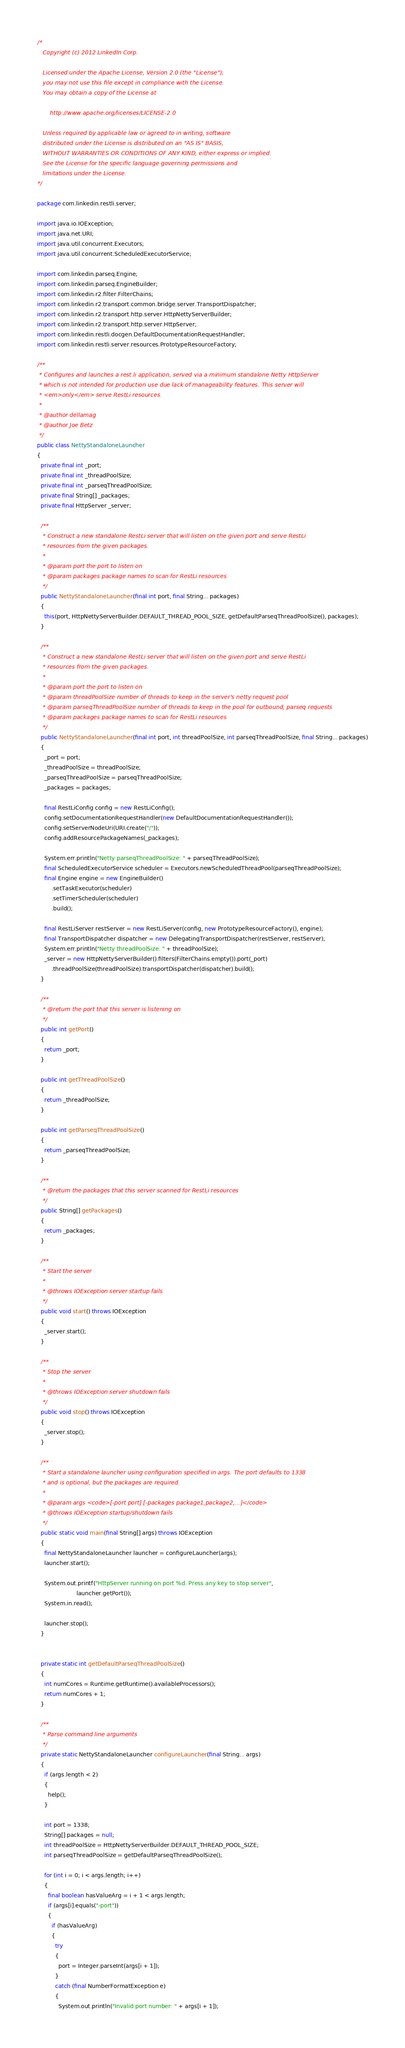<code> <loc_0><loc_0><loc_500><loc_500><_Java_>/*
   Copyright (c) 2012 LinkedIn Corp.

   Licensed under the Apache License, Version 2.0 (the "License");
   you may not use this file except in compliance with the License.
   You may obtain a copy of the License at

       http://www.apache.org/licenses/LICENSE-2.0

   Unless required by applicable law or agreed to in writing, software
   distributed under the License is distributed on an "AS IS" BASIS,
   WITHOUT WARRANTIES OR CONDITIONS OF ANY KIND, either express or implied.
   See the License for the specific language governing permissions and
   limitations under the License.
*/

package com.linkedin.restli.server;

import java.io.IOException;
import java.net.URI;
import java.util.concurrent.Executors;
import java.util.concurrent.ScheduledExecutorService;

import com.linkedin.parseq.Engine;
import com.linkedin.parseq.EngineBuilder;
import com.linkedin.r2.filter.FilterChains;
import com.linkedin.r2.transport.common.bridge.server.TransportDispatcher;
import com.linkedin.r2.transport.http.server.HttpNettyServerBuilder;
import com.linkedin.r2.transport.http.server.HttpServer;
import com.linkedin.restli.docgen.DefaultDocumentationRequestHandler;
import com.linkedin.restli.server.resources.PrototypeResourceFactory;

/**
 * Configures and launches a rest.li application, served via a minimum standalone Netty HttpServer
 * which is not intended for production use due lack of manageability features. This server will
 * <em>only</em> serve RestLi resources.
 *
 * @author dellamag
 * @author Joe Betz
 */
public class NettyStandaloneLauncher
{
  private final int _port;
  private final int _threadPoolSize;
  private final int _parseqThreadPoolSize;
  private final String[] _packages;
  private final HttpServer _server;

  /**
   * Construct a new standalone RestLi server that will listen on the given port and serve RestLi
   * resources from the given packages.
   *
   * @param port the port to listen on
   * @param packages package names to scan for RestLi resources
   */
  public NettyStandaloneLauncher(final int port, final String... packages)
  {
    this(port, HttpNettyServerBuilder.DEFAULT_THREAD_POOL_SIZE, getDefaultParseqThreadPoolSize(), packages);
  }

  /**
   * Construct a new standalone RestLi server that will listen on the given port and serve RestLi
   * resources from the given packages.
   *
   * @param port the port to listen on
   * @param threadPoolSize number of threads to keep in the server's netty request pool
   * @param parseqThreadPoolSize number of threads to keep in the pool for outbound, parseq requests
   * @param packages package names to scan for RestLi resources
   */
  public NettyStandaloneLauncher(final int port, int threadPoolSize, int parseqThreadPoolSize, final String... packages)
  {
    _port = port;
    _threadPoolSize = threadPoolSize;
    _parseqThreadPoolSize = parseqThreadPoolSize;
    _packages = packages;

    final RestLiConfig config = new RestLiConfig();
    config.setDocumentationRequestHandler(new DefaultDocumentationRequestHandler());
    config.setServerNodeUri(URI.create("/"));
    config.addResourcePackageNames(_packages);

    System.err.println("Netty parseqThreadPoolSize: " + parseqThreadPoolSize);
    final ScheduledExecutorService scheduler = Executors.newScheduledThreadPool(parseqThreadPoolSize);
    final Engine engine = new EngineBuilder()
        .setTaskExecutor(scheduler)
        .setTimerScheduler(scheduler)
        .build();

    final RestLiServer restServer = new RestLiServer(config, new PrototypeResourceFactory(), engine);
    final TransportDispatcher dispatcher = new DelegatingTransportDispatcher(restServer, restServer);
    System.err.println("Netty threadPoolSize: " + threadPoolSize);
    _server = new HttpNettyServerBuilder().filters(FilterChains.empty()).port(_port)
        .threadPoolSize(threadPoolSize).transportDispatcher(dispatcher).build();
  }

  /**
   * @return the port that this server is listening on
   */
  public int getPort()
  {
    return _port;
  }

  public int getThreadPoolSize()
  {
    return _threadPoolSize;
  }

  public int getParseqThreadPoolSize()
  {
    return _parseqThreadPoolSize;
  }

  /**
   * @return the packages that this server scanned for RestLi resources
   */
  public String[] getPackages()
  {
    return _packages;
  }

  /**
   * Start the server
   *
   * @throws IOException server startup fails
   */
  public void start() throws IOException
  {
    _server.start();
  }

  /**
   * Stop the server
   *
   * @throws IOException server shutdown fails
   */
  public void stop() throws IOException
  {
    _server.stop();
  }

  /**
   * Start a standalone launcher using configuration specified in args. The port defaults to 1338
   * and is optional, but the packages are required.
   *
   * @param args <code>[-port port] [-packages package1,package2,...]</code>
   * @throws IOException startup/shutdown fails
   */
  public static void main(final String[] args) throws IOException
  {
    final NettyStandaloneLauncher launcher = configureLauncher(args);
    launcher.start();

    System.out.printf("HttpServer running on port %d. Press any key to stop server",
                      launcher.getPort());
    System.in.read();

    launcher.stop();
  }


  private static int getDefaultParseqThreadPoolSize()
  {
    int numCores = Runtime.getRuntime().availableProcessors();
    return numCores + 1;
  }

  /**
   * Parse command line arguments
   */
  private static NettyStandaloneLauncher configureLauncher(final String... args)
  {
    if (args.length < 2)
    {
      help();
    }

    int port = 1338;
    String[] packages = null;
    int threadPoolSize = HttpNettyServerBuilder.DEFAULT_THREAD_POOL_SIZE;
    int parseqThreadPoolSize = getDefaultParseqThreadPoolSize();

    for (int i = 0; i < args.length; i++)
    {
      final boolean hasValueArg = i + 1 < args.length;
      if (args[i].equals("-port"))
      {
        if (hasValueArg)
        {
          try
          {
            port = Integer.parseInt(args[i + 1]);
          }
          catch (final NumberFormatException e)
          {
            System.out.println("Invalid port number: " + args[i + 1]);</code> 